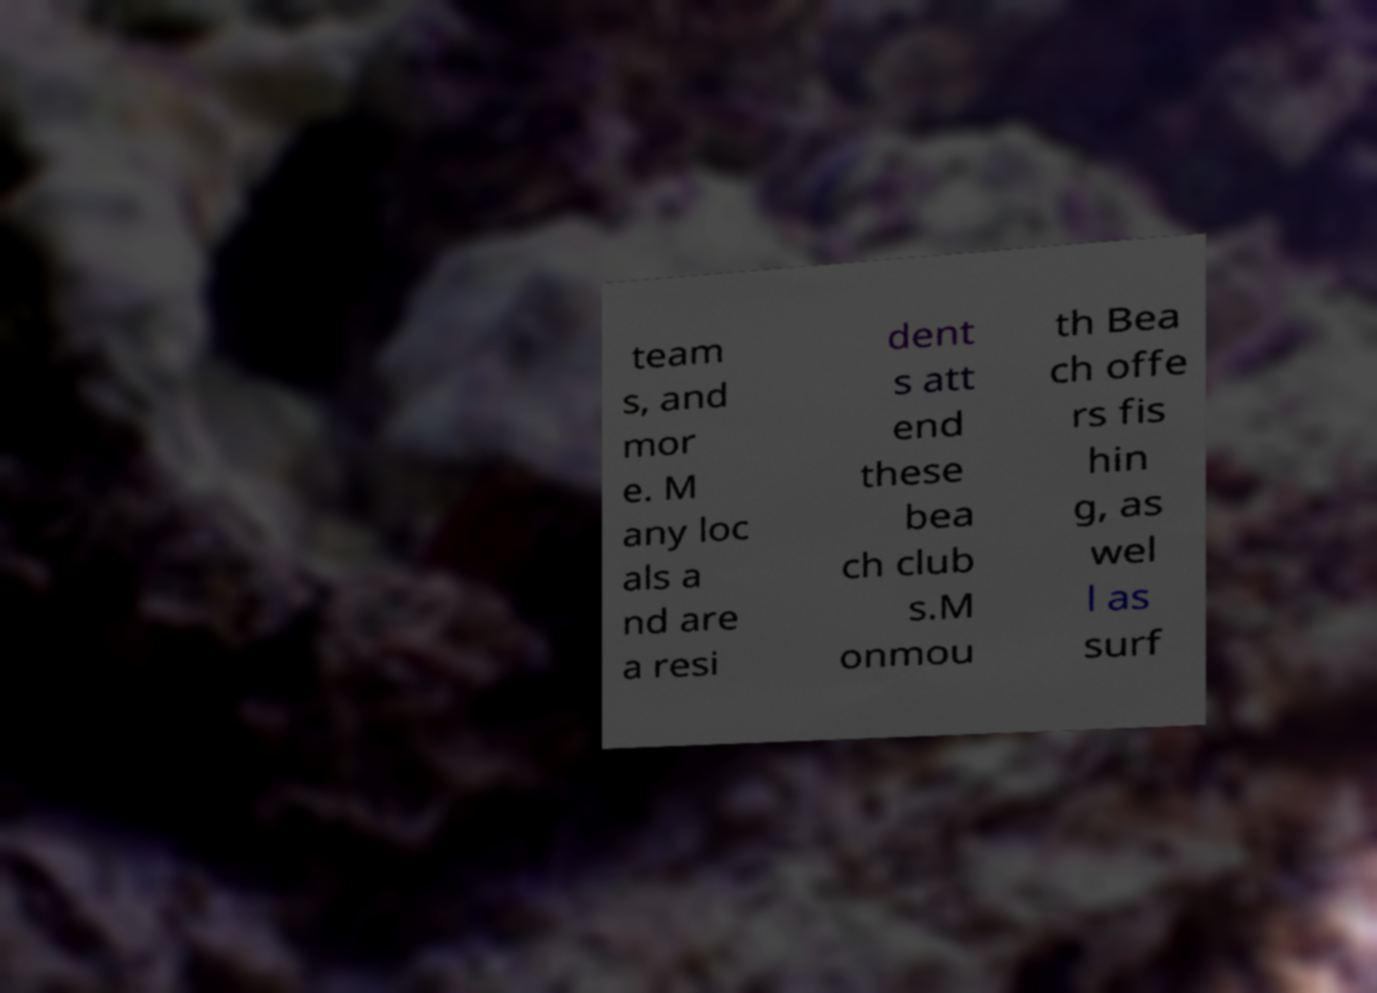Please read and relay the text visible in this image. What does it say? team s, and mor e. M any loc als a nd are a resi dent s att end these bea ch club s.M onmou th Bea ch offe rs fis hin g, as wel l as surf 